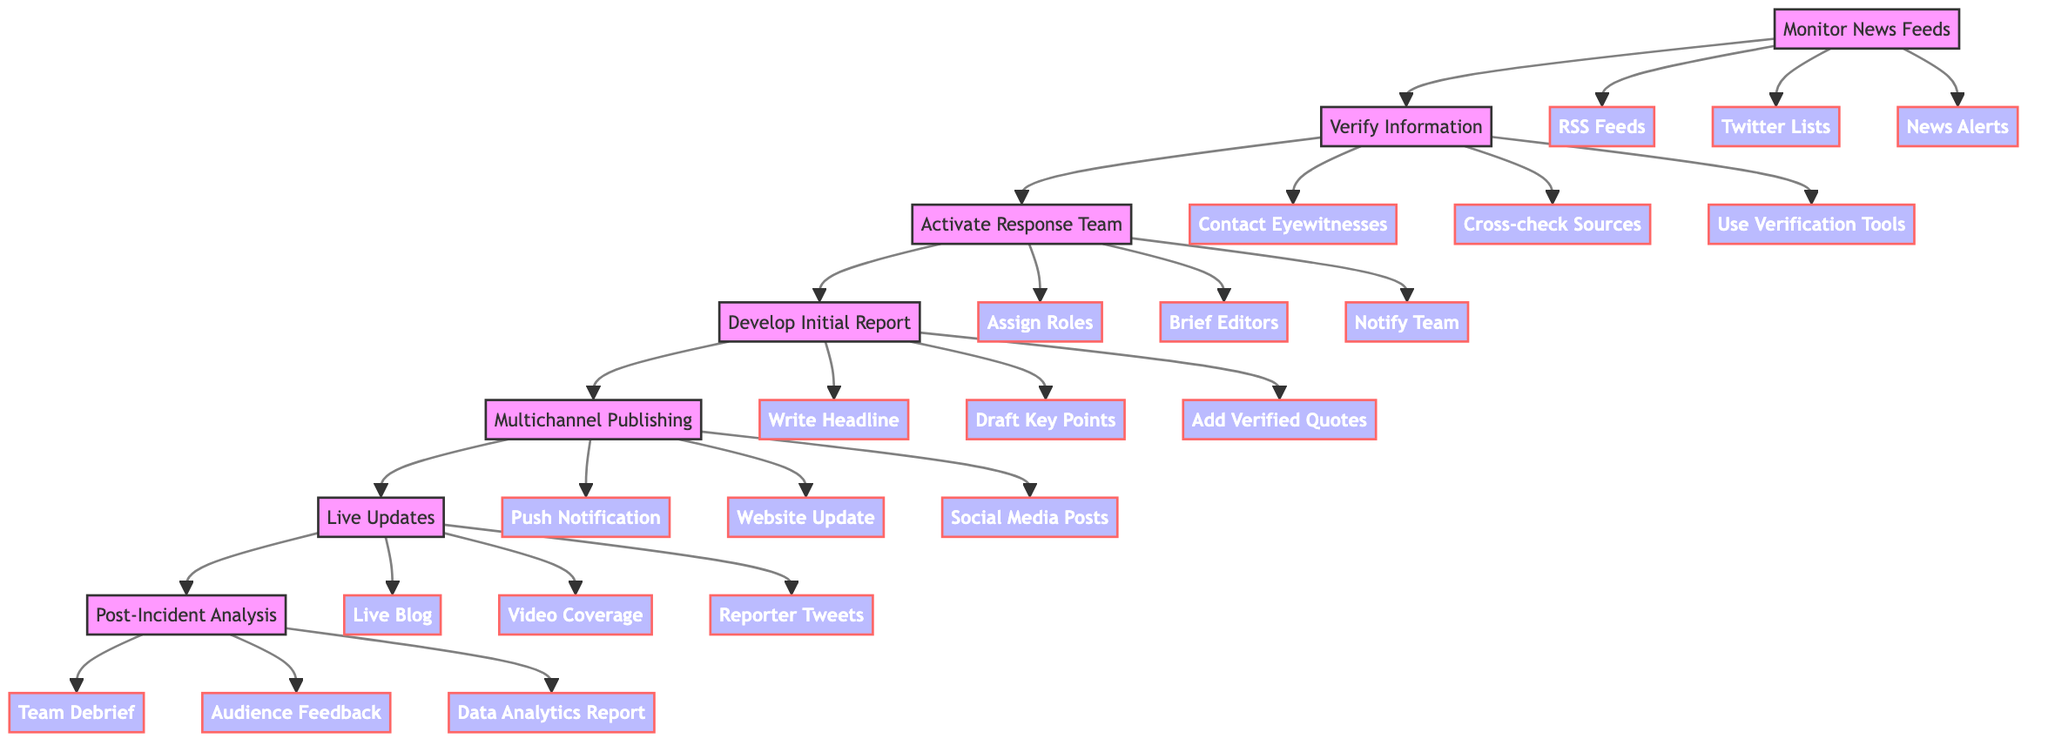What is the first step in the response plan? The diagram starts with the "Monitor News Feeds" node, indicating that this is the initial action to take.
Answer: Monitor News Feeds How many actions are listed under "Verify Information"? The "Verify Information" node connects to three specific actions: "Contact Eyewitnesses", "Cross-check Reputable Sources", and "Use Verification Tools", totaling three actions.
Answer: 3 Which node follows "Develop Initial Report"? The flowchart shows the sequence where "Develop Initial Report" directly leads to "Multichannel Publishing", indicating that Multichannel Publishing is the next step.
Answer: Multichannel Publishing List one action under "Activate Response Team". The "Activate Response Team" node includes three specific actions; any of those counts, such as "Assign Roles", would be correct in this context.
Answer: Assign Roles What is the last step in the process? The final action in the flow as per the diagram leads to "Post-Incident Analysis", marking it as the last step in the response plan.
Answer: Post-Incident Analysis How many total nodes are present in the flowchart? Counting the nodes, there are seven primary actions plus the actions under each main node leads to a total of ten nodes in the flowchart.
Answer: 10 What does the edge from "Monitor News Feeds" signify? The edge from "Monitor News Feeds" to "Verify Information" indicates a flow of actions; it signifies that monitoring feeds is a prerequisite for verifying information.
Answer: Prerequisite Identify one platform used in "Multichannel Publishing". Under the "Multichannel Publishing" node, the actions include "Push Notification", "Website Update", and "Social Media Posts", any of which can identify a platform for publishing.
Answer: Social Media Posts Which two nodes are connected to the "Live Updates"? The "Live Updates" node connects following "Multichannel Publishing" and leads to "Post-Incident Analysis", hence these are the two nodes connected to it.
Answer: Multichannel Publishing, Post-Incident Analysis 